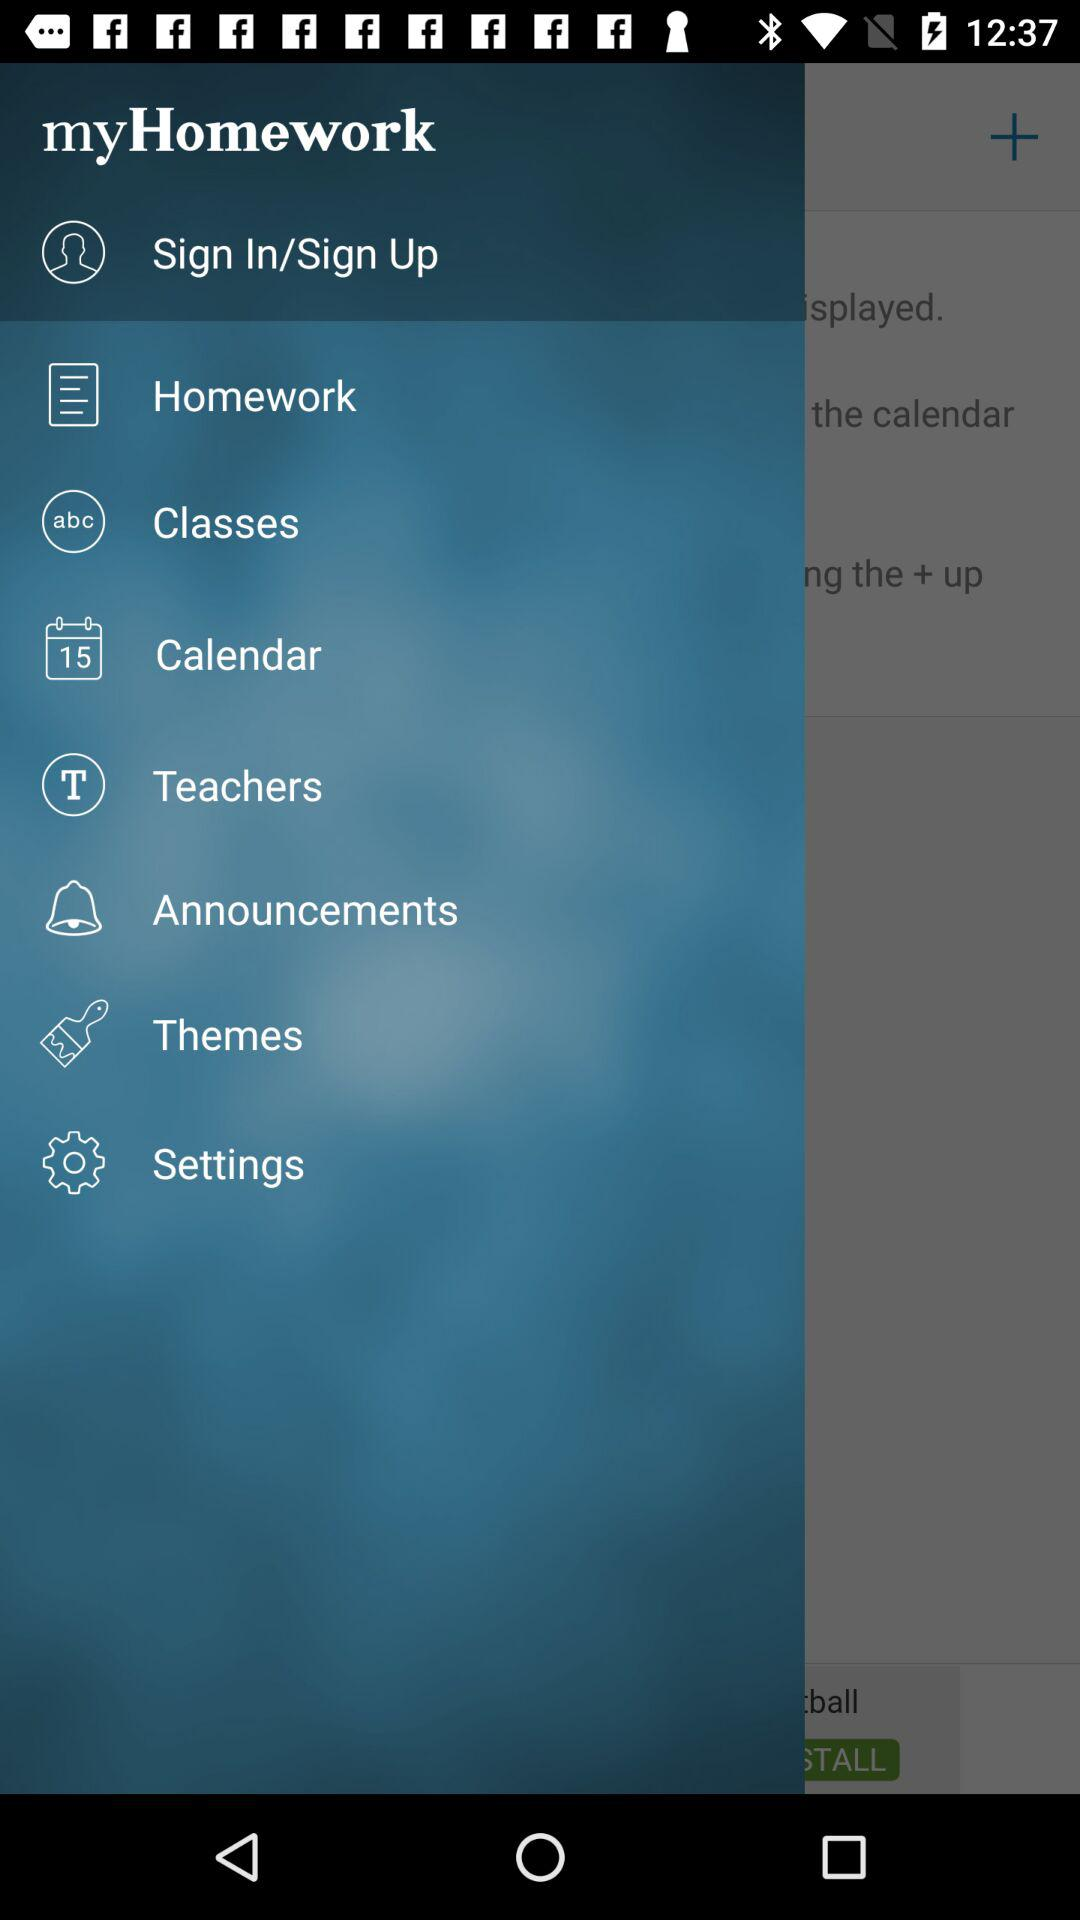What are options to Log in the Application?
When the provided information is insufficient, respond with <no answer>. <no answer> 